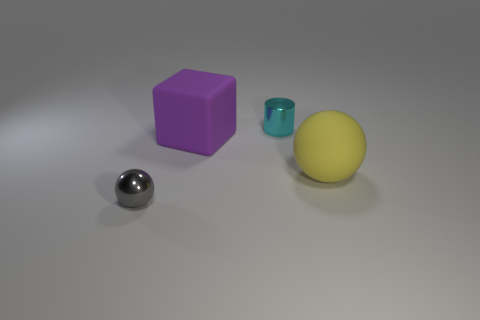Subtract all gray spheres. How many spheres are left? 1 Add 2 small gray metal cylinders. How many objects exist? 6 Subtract all cubes. How many objects are left? 3 Subtract all yellow things. Subtract all blue matte things. How many objects are left? 3 Add 4 shiny objects. How many shiny objects are left? 6 Add 3 gray cylinders. How many gray cylinders exist? 3 Subtract 0 yellow cubes. How many objects are left? 4 Subtract all gray cylinders. Subtract all cyan cubes. How many cylinders are left? 1 Subtract all blue cylinders. How many brown cubes are left? 0 